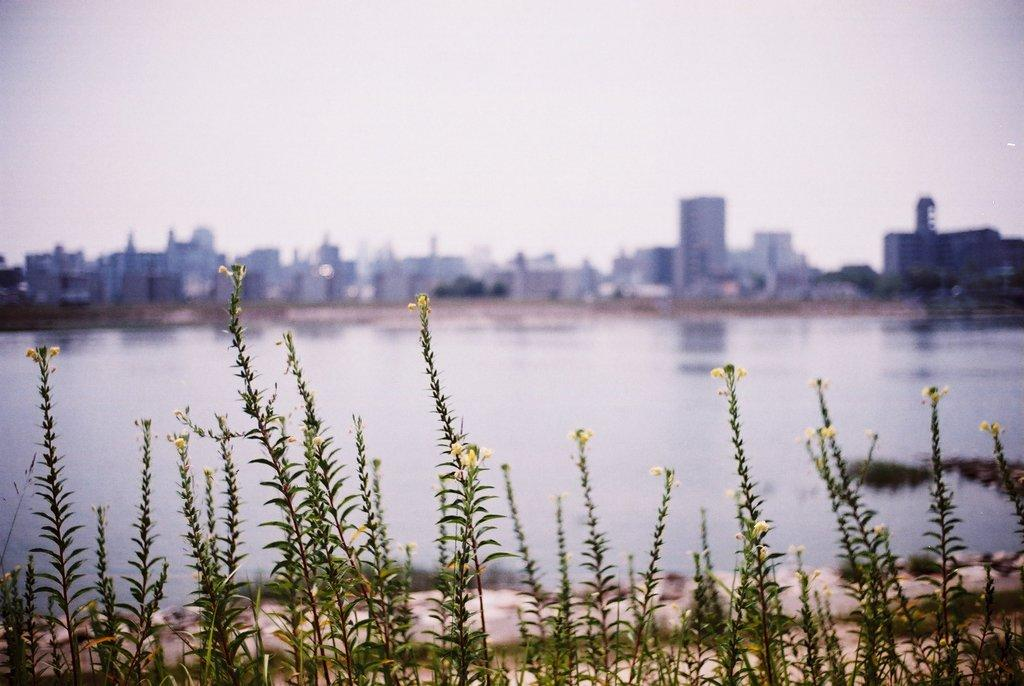What type of vegetation is visible in the front of the image? There are plants in the front of the image. What is located in the center of the image? There is water in the center of the image. What type of structures can be seen in the background of the image? There are buildings in the background of the image. Can you tell me how many skateboards are visible in the image? There are no skateboards present in the image. What type of heat source is used to warm the water in the image? There is no heat source visible in the image, and the water appears to be naturally occurring. 